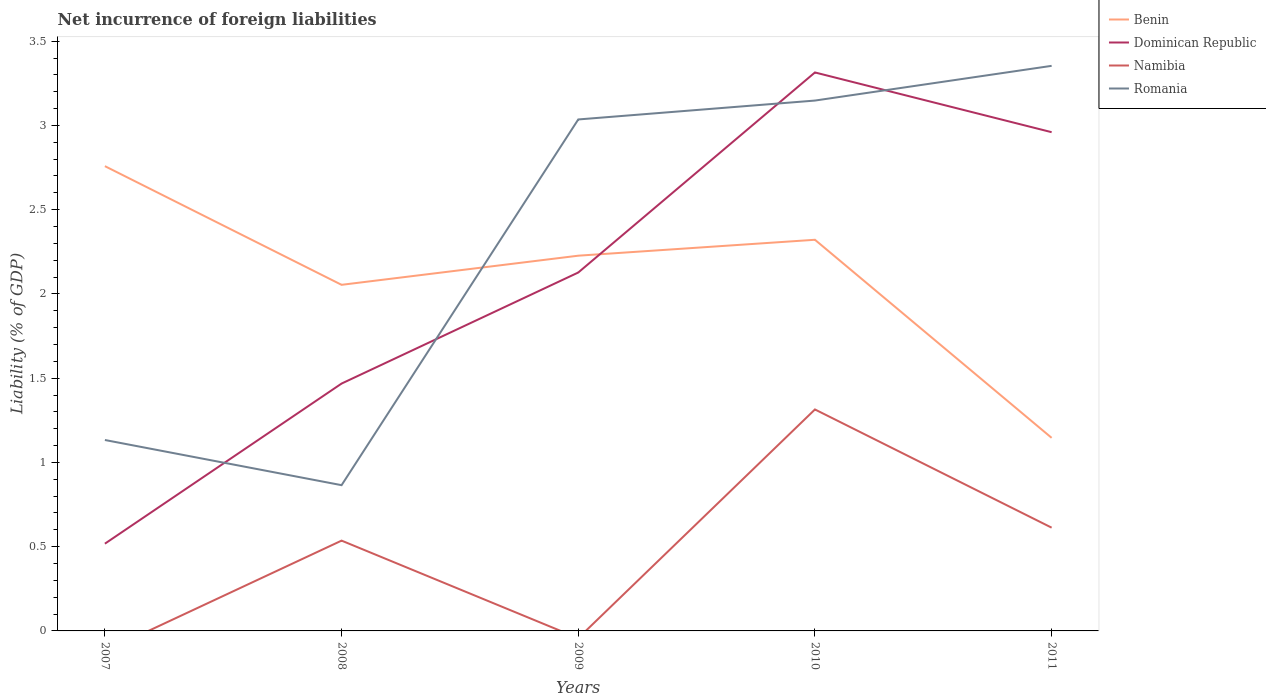Is the number of lines equal to the number of legend labels?
Provide a succinct answer. No. Across all years, what is the maximum net incurrence of foreign liabilities in Namibia?
Your answer should be very brief. 0. What is the total net incurrence of foreign liabilities in Benin in the graph?
Your answer should be very brief. 0.53. What is the difference between the highest and the second highest net incurrence of foreign liabilities in Dominican Republic?
Make the answer very short. 2.8. How many lines are there?
Ensure brevity in your answer.  4. How many years are there in the graph?
Give a very brief answer. 5. What is the difference between two consecutive major ticks on the Y-axis?
Make the answer very short. 0.5. Are the values on the major ticks of Y-axis written in scientific E-notation?
Provide a short and direct response. No. Does the graph contain grids?
Give a very brief answer. No. What is the title of the graph?
Provide a succinct answer. Net incurrence of foreign liabilities. What is the label or title of the Y-axis?
Keep it short and to the point. Liability (% of GDP). What is the Liability (% of GDP) of Benin in 2007?
Make the answer very short. 2.76. What is the Liability (% of GDP) in Dominican Republic in 2007?
Your answer should be very brief. 0.52. What is the Liability (% of GDP) in Romania in 2007?
Offer a very short reply. 1.13. What is the Liability (% of GDP) in Benin in 2008?
Make the answer very short. 2.05. What is the Liability (% of GDP) in Dominican Republic in 2008?
Offer a very short reply. 1.47. What is the Liability (% of GDP) in Namibia in 2008?
Give a very brief answer. 0.54. What is the Liability (% of GDP) in Romania in 2008?
Provide a succinct answer. 0.87. What is the Liability (% of GDP) of Benin in 2009?
Provide a short and direct response. 2.23. What is the Liability (% of GDP) in Dominican Republic in 2009?
Provide a succinct answer. 2.13. What is the Liability (% of GDP) of Namibia in 2009?
Give a very brief answer. 0. What is the Liability (% of GDP) in Romania in 2009?
Offer a terse response. 3.04. What is the Liability (% of GDP) in Benin in 2010?
Provide a short and direct response. 2.32. What is the Liability (% of GDP) in Dominican Republic in 2010?
Keep it short and to the point. 3.31. What is the Liability (% of GDP) of Namibia in 2010?
Provide a short and direct response. 1.31. What is the Liability (% of GDP) in Romania in 2010?
Your response must be concise. 3.15. What is the Liability (% of GDP) of Benin in 2011?
Your answer should be compact. 1.15. What is the Liability (% of GDP) of Dominican Republic in 2011?
Provide a short and direct response. 2.96. What is the Liability (% of GDP) of Namibia in 2011?
Offer a very short reply. 0.61. What is the Liability (% of GDP) of Romania in 2011?
Give a very brief answer. 3.35. Across all years, what is the maximum Liability (% of GDP) of Benin?
Ensure brevity in your answer.  2.76. Across all years, what is the maximum Liability (% of GDP) of Dominican Republic?
Ensure brevity in your answer.  3.31. Across all years, what is the maximum Liability (% of GDP) in Namibia?
Keep it short and to the point. 1.31. Across all years, what is the maximum Liability (% of GDP) of Romania?
Provide a short and direct response. 3.35. Across all years, what is the minimum Liability (% of GDP) in Benin?
Offer a terse response. 1.15. Across all years, what is the minimum Liability (% of GDP) of Dominican Republic?
Offer a terse response. 0.52. Across all years, what is the minimum Liability (% of GDP) of Namibia?
Ensure brevity in your answer.  0. Across all years, what is the minimum Liability (% of GDP) of Romania?
Provide a short and direct response. 0.87. What is the total Liability (% of GDP) of Benin in the graph?
Your answer should be compact. 10.51. What is the total Liability (% of GDP) of Dominican Republic in the graph?
Provide a short and direct response. 10.39. What is the total Liability (% of GDP) of Namibia in the graph?
Your response must be concise. 2.46. What is the total Liability (% of GDP) of Romania in the graph?
Provide a succinct answer. 11.53. What is the difference between the Liability (% of GDP) in Benin in 2007 and that in 2008?
Your answer should be compact. 0.7. What is the difference between the Liability (% of GDP) of Dominican Republic in 2007 and that in 2008?
Keep it short and to the point. -0.95. What is the difference between the Liability (% of GDP) in Romania in 2007 and that in 2008?
Make the answer very short. 0.27. What is the difference between the Liability (% of GDP) in Benin in 2007 and that in 2009?
Offer a very short reply. 0.53. What is the difference between the Liability (% of GDP) of Dominican Republic in 2007 and that in 2009?
Keep it short and to the point. -1.61. What is the difference between the Liability (% of GDP) of Romania in 2007 and that in 2009?
Ensure brevity in your answer.  -1.9. What is the difference between the Liability (% of GDP) in Benin in 2007 and that in 2010?
Keep it short and to the point. 0.44. What is the difference between the Liability (% of GDP) of Dominican Republic in 2007 and that in 2010?
Provide a succinct answer. -2.8. What is the difference between the Liability (% of GDP) in Romania in 2007 and that in 2010?
Ensure brevity in your answer.  -2.01. What is the difference between the Liability (% of GDP) of Benin in 2007 and that in 2011?
Your answer should be very brief. 1.61. What is the difference between the Liability (% of GDP) of Dominican Republic in 2007 and that in 2011?
Keep it short and to the point. -2.44. What is the difference between the Liability (% of GDP) in Romania in 2007 and that in 2011?
Offer a terse response. -2.22. What is the difference between the Liability (% of GDP) of Benin in 2008 and that in 2009?
Your answer should be compact. -0.17. What is the difference between the Liability (% of GDP) of Dominican Republic in 2008 and that in 2009?
Keep it short and to the point. -0.66. What is the difference between the Liability (% of GDP) of Romania in 2008 and that in 2009?
Give a very brief answer. -2.17. What is the difference between the Liability (% of GDP) in Benin in 2008 and that in 2010?
Make the answer very short. -0.27. What is the difference between the Liability (% of GDP) of Dominican Republic in 2008 and that in 2010?
Provide a succinct answer. -1.85. What is the difference between the Liability (% of GDP) in Namibia in 2008 and that in 2010?
Ensure brevity in your answer.  -0.78. What is the difference between the Liability (% of GDP) of Romania in 2008 and that in 2010?
Keep it short and to the point. -2.28. What is the difference between the Liability (% of GDP) of Benin in 2008 and that in 2011?
Your response must be concise. 0.91. What is the difference between the Liability (% of GDP) of Dominican Republic in 2008 and that in 2011?
Give a very brief answer. -1.49. What is the difference between the Liability (% of GDP) in Namibia in 2008 and that in 2011?
Offer a terse response. -0.08. What is the difference between the Liability (% of GDP) of Romania in 2008 and that in 2011?
Provide a short and direct response. -2.49. What is the difference between the Liability (% of GDP) of Benin in 2009 and that in 2010?
Give a very brief answer. -0.09. What is the difference between the Liability (% of GDP) in Dominican Republic in 2009 and that in 2010?
Offer a very short reply. -1.19. What is the difference between the Liability (% of GDP) in Romania in 2009 and that in 2010?
Offer a terse response. -0.11. What is the difference between the Liability (% of GDP) in Benin in 2009 and that in 2011?
Offer a very short reply. 1.08. What is the difference between the Liability (% of GDP) of Dominican Republic in 2009 and that in 2011?
Give a very brief answer. -0.83. What is the difference between the Liability (% of GDP) in Romania in 2009 and that in 2011?
Make the answer very short. -0.32. What is the difference between the Liability (% of GDP) of Benin in 2010 and that in 2011?
Ensure brevity in your answer.  1.18. What is the difference between the Liability (% of GDP) of Dominican Republic in 2010 and that in 2011?
Make the answer very short. 0.35. What is the difference between the Liability (% of GDP) in Namibia in 2010 and that in 2011?
Offer a very short reply. 0.7. What is the difference between the Liability (% of GDP) of Romania in 2010 and that in 2011?
Ensure brevity in your answer.  -0.21. What is the difference between the Liability (% of GDP) in Benin in 2007 and the Liability (% of GDP) in Dominican Republic in 2008?
Make the answer very short. 1.29. What is the difference between the Liability (% of GDP) in Benin in 2007 and the Liability (% of GDP) in Namibia in 2008?
Offer a very short reply. 2.22. What is the difference between the Liability (% of GDP) in Benin in 2007 and the Liability (% of GDP) in Romania in 2008?
Provide a short and direct response. 1.89. What is the difference between the Liability (% of GDP) in Dominican Republic in 2007 and the Liability (% of GDP) in Namibia in 2008?
Give a very brief answer. -0.02. What is the difference between the Liability (% of GDP) of Dominican Republic in 2007 and the Liability (% of GDP) of Romania in 2008?
Provide a short and direct response. -0.35. What is the difference between the Liability (% of GDP) in Benin in 2007 and the Liability (% of GDP) in Dominican Republic in 2009?
Offer a very short reply. 0.63. What is the difference between the Liability (% of GDP) in Benin in 2007 and the Liability (% of GDP) in Romania in 2009?
Your answer should be compact. -0.28. What is the difference between the Liability (% of GDP) in Dominican Republic in 2007 and the Liability (% of GDP) in Romania in 2009?
Your answer should be very brief. -2.52. What is the difference between the Liability (% of GDP) of Benin in 2007 and the Liability (% of GDP) of Dominican Republic in 2010?
Give a very brief answer. -0.56. What is the difference between the Liability (% of GDP) of Benin in 2007 and the Liability (% of GDP) of Namibia in 2010?
Offer a terse response. 1.44. What is the difference between the Liability (% of GDP) of Benin in 2007 and the Liability (% of GDP) of Romania in 2010?
Give a very brief answer. -0.39. What is the difference between the Liability (% of GDP) of Dominican Republic in 2007 and the Liability (% of GDP) of Namibia in 2010?
Provide a short and direct response. -0.8. What is the difference between the Liability (% of GDP) of Dominican Republic in 2007 and the Liability (% of GDP) of Romania in 2010?
Keep it short and to the point. -2.63. What is the difference between the Liability (% of GDP) of Benin in 2007 and the Liability (% of GDP) of Dominican Republic in 2011?
Ensure brevity in your answer.  -0.2. What is the difference between the Liability (% of GDP) in Benin in 2007 and the Liability (% of GDP) in Namibia in 2011?
Your response must be concise. 2.15. What is the difference between the Liability (% of GDP) in Benin in 2007 and the Liability (% of GDP) in Romania in 2011?
Your answer should be compact. -0.6. What is the difference between the Liability (% of GDP) of Dominican Republic in 2007 and the Liability (% of GDP) of Namibia in 2011?
Your answer should be very brief. -0.1. What is the difference between the Liability (% of GDP) of Dominican Republic in 2007 and the Liability (% of GDP) of Romania in 2011?
Give a very brief answer. -2.84. What is the difference between the Liability (% of GDP) of Benin in 2008 and the Liability (% of GDP) of Dominican Republic in 2009?
Your answer should be compact. -0.07. What is the difference between the Liability (% of GDP) of Benin in 2008 and the Liability (% of GDP) of Romania in 2009?
Your response must be concise. -0.98. What is the difference between the Liability (% of GDP) in Dominican Republic in 2008 and the Liability (% of GDP) in Romania in 2009?
Ensure brevity in your answer.  -1.57. What is the difference between the Liability (% of GDP) in Namibia in 2008 and the Liability (% of GDP) in Romania in 2009?
Offer a terse response. -2.5. What is the difference between the Liability (% of GDP) of Benin in 2008 and the Liability (% of GDP) of Dominican Republic in 2010?
Give a very brief answer. -1.26. What is the difference between the Liability (% of GDP) in Benin in 2008 and the Liability (% of GDP) in Namibia in 2010?
Your answer should be very brief. 0.74. What is the difference between the Liability (% of GDP) of Benin in 2008 and the Liability (% of GDP) of Romania in 2010?
Provide a succinct answer. -1.09. What is the difference between the Liability (% of GDP) in Dominican Republic in 2008 and the Liability (% of GDP) in Namibia in 2010?
Provide a short and direct response. 0.15. What is the difference between the Liability (% of GDP) of Dominican Republic in 2008 and the Liability (% of GDP) of Romania in 2010?
Your response must be concise. -1.68. What is the difference between the Liability (% of GDP) of Namibia in 2008 and the Liability (% of GDP) of Romania in 2010?
Your response must be concise. -2.61. What is the difference between the Liability (% of GDP) in Benin in 2008 and the Liability (% of GDP) in Dominican Republic in 2011?
Provide a succinct answer. -0.91. What is the difference between the Liability (% of GDP) in Benin in 2008 and the Liability (% of GDP) in Namibia in 2011?
Provide a succinct answer. 1.44. What is the difference between the Liability (% of GDP) of Benin in 2008 and the Liability (% of GDP) of Romania in 2011?
Offer a terse response. -1.3. What is the difference between the Liability (% of GDP) of Dominican Republic in 2008 and the Liability (% of GDP) of Namibia in 2011?
Give a very brief answer. 0.86. What is the difference between the Liability (% of GDP) in Dominican Republic in 2008 and the Liability (% of GDP) in Romania in 2011?
Your response must be concise. -1.89. What is the difference between the Liability (% of GDP) of Namibia in 2008 and the Liability (% of GDP) of Romania in 2011?
Make the answer very short. -2.82. What is the difference between the Liability (% of GDP) in Benin in 2009 and the Liability (% of GDP) in Dominican Republic in 2010?
Offer a very short reply. -1.09. What is the difference between the Liability (% of GDP) of Benin in 2009 and the Liability (% of GDP) of Namibia in 2010?
Your answer should be compact. 0.91. What is the difference between the Liability (% of GDP) in Benin in 2009 and the Liability (% of GDP) in Romania in 2010?
Give a very brief answer. -0.92. What is the difference between the Liability (% of GDP) in Dominican Republic in 2009 and the Liability (% of GDP) in Namibia in 2010?
Provide a short and direct response. 0.81. What is the difference between the Liability (% of GDP) of Dominican Republic in 2009 and the Liability (% of GDP) of Romania in 2010?
Make the answer very short. -1.02. What is the difference between the Liability (% of GDP) of Benin in 2009 and the Liability (% of GDP) of Dominican Republic in 2011?
Offer a very short reply. -0.73. What is the difference between the Liability (% of GDP) of Benin in 2009 and the Liability (% of GDP) of Namibia in 2011?
Your response must be concise. 1.61. What is the difference between the Liability (% of GDP) of Benin in 2009 and the Liability (% of GDP) of Romania in 2011?
Your answer should be very brief. -1.13. What is the difference between the Liability (% of GDP) of Dominican Republic in 2009 and the Liability (% of GDP) of Namibia in 2011?
Your answer should be compact. 1.51. What is the difference between the Liability (% of GDP) in Dominican Republic in 2009 and the Liability (% of GDP) in Romania in 2011?
Your answer should be compact. -1.23. What is the difference between the Liability (% of GDP) in Benin in 2010 and the Liability (% of GDP) in Dominican Republic in 2011?
Your response must be concise. -0.64. What is the difference between the Liability (% of GDP) of Benin in 2010 and the Liability (% of GDP) of Namibia in 2011?
Provide a short and direct response. 1.71. What is the difference between the Liability (% of GDP) in Benin in 2010 and the Liability (% of GDP) in Romania in 2011?
Your answer should be compact. -1.03. What is the difference between the Liability (% of GDP) in Dominican Republic in 2010 and the Liability (% of GDP) in Namibia in 2011?
Offer a very short reply. 2.7. What is the difference between the Liability (% of GDP) in Dominican Republic in 2010 and the Liability (% of GDP) in Romania in 2011?
Your answer should be compact. -0.04. What is the difference between the Liability (% of GDP) of Namibia in 2010 and the Liability (% of GDP) of Romania in 2011?
Make the answer very short. -2.04. What is the average Liability (% of GDP) in Benin per year?
Keep it short and to the point. 2.1. What is the average Liability (% of GDP) in Dominican Republic per year?
Your answer should be very brief. 2.08. What is the average Liability (% of GDP) in Namibia per year?
Offer a terse response. 0.49. What is the average Liability (% of GDP) in Romania per year?
Ensure brevity in your answer.  2.31. In the year 2007, what is the difference between the Liability (% of GDP) in Benin and Liability (% of GDP) in Dominican Republic?
Ensure brevity in your answer.  2.24. In the year 2007, what is the difference between the Liability (% of GDP) of Benin and Liability (% of GDP) of Romania?
Offer a very short reply. 1.63. In the year 2007, what is the difference between the Liability (% of GDP) in Dominican Republic and Liability (% of GDP) in Romania?
Give a very brief answer. -0.62. In the year 2008, what is the difference between the Liability (% of GDP) of Benin and Liability (% of GDP) of Dominican Republic?
Your response must be concise. 0.59. In the year 2008, what is the difference between the Liability (% of GDP) of Benin and Liability (% of GDP) of Namibia?
Offer a terse response. 1.52. In the year 2008, what is the difference between the Liability (% of GDP) in Benin and Liability (% of GDP) in Romania?
Your answer should be compact. 1.19. In the year 2008, what is the difference between the Liability (% of GDP) of Dominican Republic and Liability (% of GDP) of Namibia?
Ensure brevity in your answer.  0.93. In the year 2008, what is the difference between the Liability (% of GDP) of Dominican Republic and Liability (% of GDP) of Romania?
Your answer should be very brief. 0.6. In the year 2008, what is the difference between the Liability (% of GDP) of Namibia and Liability (% of GDP) of Romania?
Ensure brevity in your answer.  -0.33. In the year 2009, what is the difference between the Liability (% of GDP) of Benin and Liability (% of GDP) of Dominican Republic?
Your answer should be compact. 0.1. In the year 2009, what is the difference between the Liability (% of GDP) of Benin and Liability (% of GDP) of Romania?
Your response must be concise. -0.81. In the year 2009, what is the difference between the Liability (% of GDP) in Dominican Republic and Liability (% of GDP) in Romania?
Your response must be concise. -0.91. In the year 2010, what is the difference between the Liability (% of GDP) in Benin and Liability (% of GDP) in Dominican Republic?
Your response must be concise. -0.99. In the year 2010, what is the difference between the Liability (% of GDP) of Benin and Liability (% of GDP) of Namibia?
Your response must be concise. 1.01. In the year 2010, what is the difference between the Liability (% of GDP) of Benin and Liability (% of GDP) of Romania?
Offer a terse response. -0.83. In the year 2010, what is the difference between the Liability (% of GDP) of Dominican Republic and Liability (% of GDP) of Namibia?
Give a very brief answer. 2. In the year 2010, what is the difference between the Liability (% of GDP) in Dominican Republic and Liability (% of GDP) in Romania?
Keep it short and to the point. 0.17. In the year 2010, what is the difference between the Liability (% of GDP) in Namibia and Liability (% of GDP) in Romania?
Give a very brief answer. -1.83. In the year 2011, what is the difference between the Liability (% of GDP) of Benin and Liability (% of GDP) of Dominican Republic?
Give a very brief answer. -1.81. In the year 2011, what is the difference between the Liability (% of GDP) of Benin and Liability (% of GDP) of Namibia?
Provide a succinct answer. 0.53. In the year 2011, what is the difference between the Liability (% of GDP) of Benin and Liability (% of GDP) of Romania?
Make the answer very short. -2.21. In the year 2011, what is the difference between the Liability (% of GDP) in Dominican Republic and Liability (% of GDP) in Namibia?
Your answer should be compact. 2.35. In the year 2011, what is the difference between the Liability (% of GDP) in Dominican Republic and Liability (% of GDP) in Romania?
Your response must be concise. -0.39. In the year 2011, what is the difference between the Liability (% of GDP) of Namibia and Liability (% of GDP) of Romania?
Ensure brevity in your answer.  -2.74. What is the ratio of the Liability (% of GDP) in Benin in 2007 to that in 2008?
Provide a short and direct response. 1.34. What is the ratio of the Liability (% of GDP) in Dominican Republic in 2007 to that in 2008?
Provide a succinct answer. 0.35. What is the ratio of the Liability (% of GDP) in Romania in 2007 to that in 2008?
Offer a very short reply. 1.31. What is the ratio of the Liability (% of GDP) of Benin in 2007 to that in 2009?
Provide a short and direct response. 1.24. What is the ratio of the Liability (% of GDP) in Dominican Republic in 2007 to that in 2009?
Ensure brevity in your answer.  0.24. What is the ratio of the Liability (% of GDP) of Romania in 2007 to that in 2009?
Give a very brief answer. 0.37. What is the ratio of the Liability (% of GDP) of Benin in 2007 to that in 2010?
Offer a very short reply. 1.19. What is the ratio of the Liability (% of GDP) in Dominican Republic in 2007 to that in 2010?
Offer a very short reply. 0.16. What is the ratio of the Liability (% of GDP) of Romania in 2007 to that in 2010?
Make the answer very short. 0.36. What is the ratio of the Liability (% of GDP) in Benin in 2007 to that in 2011?
Your answer should be very brief. 2.41. What is the ratio of the Liability (% of GDP) in Dominican Republic in 2007 to that in 2011?
Provide a succinct answer. 0.17. What is the ratio of the Liability (% of GDP) of Romania in 2007 to that in 2011?
Your answer should be compact. 0.34. What is the ratio of the Liability (% of GDP) of Benin in 2008 to that in 2009?
Make the answer very short. 0.92. What is the ratio of the Liability (% of GDP) of Dominican Republic in 2008 to that in 2009?
Offer a very short reply. 0.69. What is the ratio of the Liability (% of GDP) in Romania in 2008 to that in 2009?
Ensure brevity in your answer.  0.28. What is the ratio of the Liability (% of GDP) of Benin in 2008 to that in 2010?
Your answer should be very brief. 0.88. What is the ratio of the Liability (% of GDP) of Dominican Republic in 2008 to that in 2010?
Provide a short and direct response. 0.44. What is the ratio of the Liability (% of GDP) of Namibia in 2008 to that in 2010?
Provide a succinct answer. 0.41. What is the ratio of the Liability (% of GDP) in Romania in 2008 to that in 2010?
Offer a very short reply. 0.27. What is the ratio of the Liability (% of GDP) of Benin in 2008 to that in 2011?
Provide a short and direct response. 1.79. What is the ratio of the Liability (% of GDP) of Dominican Republic in 2008 to that in 2011?
Make the answer very short. 0.5. What is the ratio of the Liability (% of GDP) of Namibia in 2008 to that in 2011?
Offer a very short reply. 0.87. What is the ratio of the Liability (% of GDP) of Romania in 2008 to that in 2011?
Your answer should be compact. 0.26. What is the ratio of the Liability (% of GDP) of Benin in 2009 to that in 2010?
Give a very brief answer. 0.96. What is the ratio of the Liability (% of GDP) of Dominican Republic in 2009 to that in 2010?
Keep it short and to the point. 0.64. What is the ratio of the Liability (% of GDP) of Romania in 2009 to that in 2010?
Offer a very short reply. 0.96. What is the ratio of the Liability (% of GDP) of Benin in 2009 to that in 2011?
Make the answer very short. 1.94. What is the ratio of the Liability (% of GDP) of Dominican Republic in 2009 to that in 2011?
Your answer should be compact. 0.72. What is the ratio of the Liability (% of GDP) of Romania in 2009 to that in 2011?
Your response must be concise. 0.91. What is the ratio of the Liability (% of GDP) of Benin in 2010 to that in 2011?
Offer a terse response. 2.03. What is the ratio of the Liability (% of GDP) in Dominican Republic in 2010 to that in 2011?
Provide a short and direct response. 1.12. What is the ratio of the Liability (% of GDP) in Namibia in 2010 to that in 2011?
Your answer should be very brief. 2.14. What is the ratio of the Liability (% of GDP) in Romania in 2010 to that in 2011?
Offer a very short reply. 0.94. What is the difference between the highest and the second highest Liability (% of GDP) in Benin?
Offer a very short reply. 0.44. What is the difference between the highest and the second highest Liability (% of GDP) of Dominican Republic?
Give a very brief answer. 0.35. What is the difference between the highest and the second highest Liability (% of GDP) in Namibia?
Offer a very short reply. 0.7. What is the difference between the highest and the second highest Liability (% of GDP) in Romania?
Ensure brevity in your answer.  0.21. What is the difference between the highest and the lowest Liability (% of GDP) of Benin?
Give a very brief answer. 1.61. What is the difference between the highest and the lowest Liability (% of GDP) in Dominican Republic?
Ensure brevity in your answer.  2.8. What is the difference between the highest and the lowest Liability (% of GDP) of Namibia?
Provide a succinct answer. 1.31. What is the difference between the highest and the lowest Liability (% of GDP) of Romania?
Make the answer very short. 2.49. 